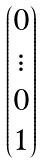Convert formula to latex. <formula><loc_0><loc_0><loc_500><loc_500>\begin{pmatrix} 0 \\ \vdots \\ 0 \\ 1 \end{pmatrix}</formula> 